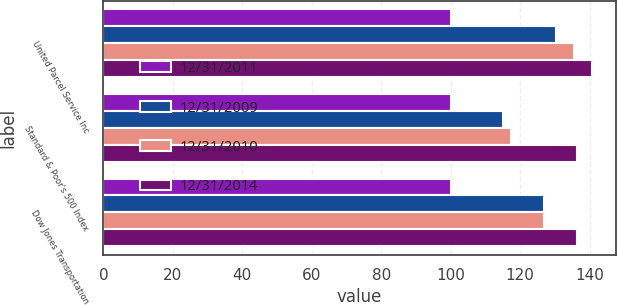Convert chart to OTSL. <chart><loc_0><loc_0><loc_500><loc_500><stacked_bar_chart><ecel><fcel>United Parcel Service Inc<fcel>Standard & Poor's 500 Index<fcel>Dow Jones Transportation<nl><fcel>12/31/2011<fcel>100<fcel>100<fcel>100<nl><fcel>12/31/2009<fcel>130.29<fcel>115.06<fcel>126.74<nl><fcel>12/31/2010<fcel>135.35<fcel>117.48<fcel>126.75<nl><fcel>12/31/2014<fcel>140.54<fcel>136.26<fcel>136.24<nl></chart> 